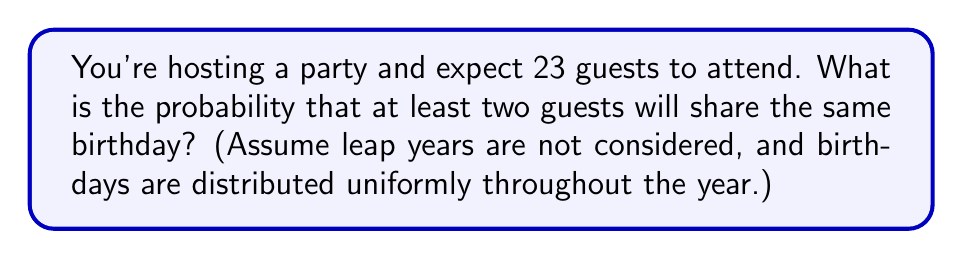Help me with this question. Let's approach this step-by-step:

1) First, it's easier to calculate the probability that no two guests share a birthday and then subtract this from 1 to get our answer.

2) The probability of all 23 guests having different birthdays is:

   $$\frac{365}{365} \cdot \frac{364}{365} \cdot \frac{363}{365} \cdot ... \cdot \frac{343}{365}$$

3) This can be written as:

   $$\prod_{i=0}^{22} \frac{365-i}{365}$$

4) Calculate this value:
   
   $$\approx 0.4927$$

5) This means the probability that at least two guests share a birthday is:

   $$1 - 0.4927 = 0.5073$$

6) Convert to a percentage:

   $$0.5073 \cdot 100\% = 50.73\%$$

This result is known as the "Birthday Paradox" or "Birthday Problem". It might seem counterintuitive that in a group of just 23 people, there's a greater than 50% chance of a shared birthday.
Answer: 50.73% 